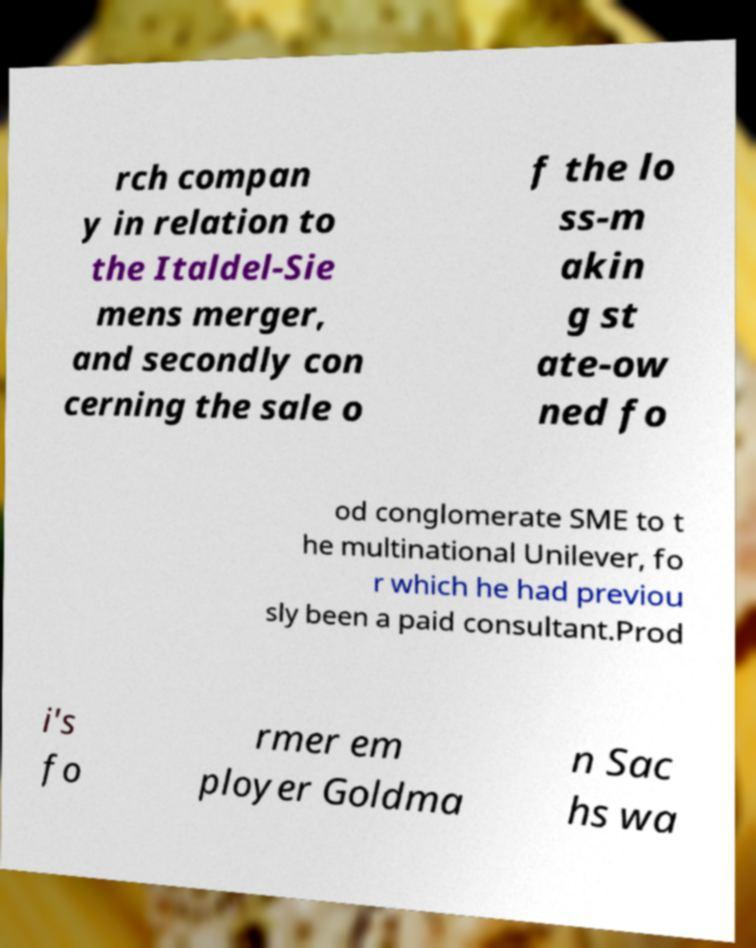Please read and relay the text visible in this image. What does it say? rch compan y in relation to the Italdel-Sie mens merger, and secondly con cerning the sale o f the lo ss-m akin g st ate-ow ned fo od conglomerate SME to t he multinational Unilever, fo r which he had previou sly been a paid consultant.Prod i's fo rmer em ployer Goldma n Sac hs wa 